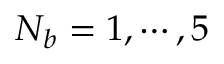Convert formula to latex. <formula><loc_0><loc_0><loc_500><loc_500>N _ { b } = 1 , \cdots , 5</formula> 